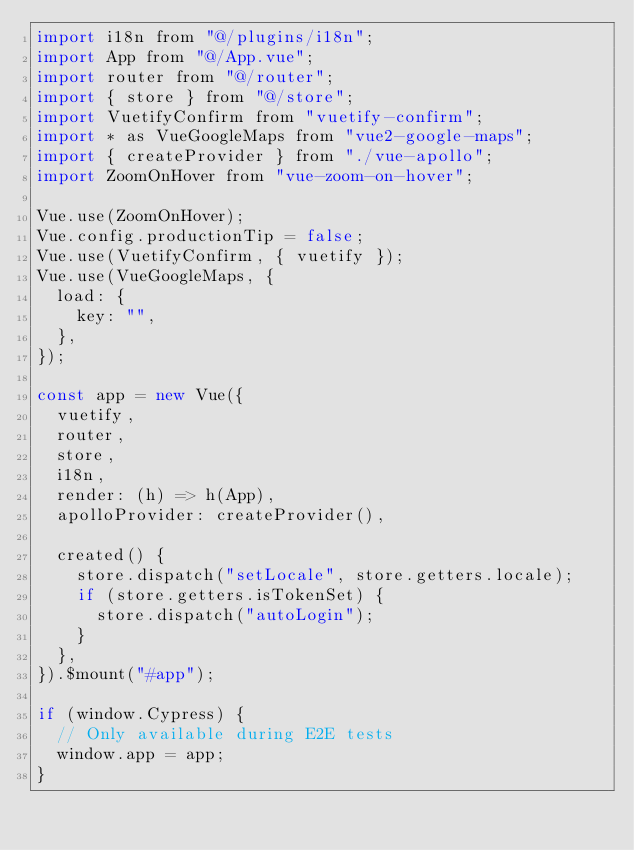Convert code to text. <code><loc_0><loc_0><loc_500><loc_500><_JavaScript_>import i18n from "@/plugins/i18n";
import App from "@/App.vue";
import router from "@/router";
import { store } from "@/store";
import VuetifyConfirm from "vuetify-confirm";
import * as VueGoogleMaps from "vue2-google-maps";
import { createProvider } from "./vue-apollo";
import ZoomOnHover from "vue-zoom-on-hover";

Vue.use(ZoomOnHover);
Vue.config.productionTip = false;
Vue.use(VuetifyConfirm, { vuetify });
Vue.use(VueGoogleMaps, {
  load: {
    key: "",
  },
});

const app = new Vue({
  vuetify,
  router,
  store,
  i18n,
  render: (h) => h(App),
  apolloProvider: createProvider(),

  created() {
    store.dispatch("setLocale", store.getters.locale);
    if (store.getters.isTokenSet) {
      store.dispatch("autoLogin");
    }
  },
}).$mount("#app");

if (window.Cypress) {
  // Only available during E2E tests
  window.app = app;
}
</code> 